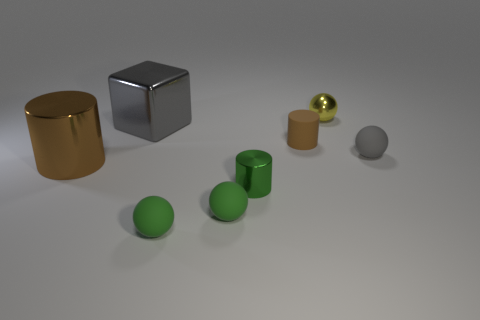Do the rubber cylinder and the large metallic cylinder have the same color?
Ensure brevity in your answer.  Yes. There is a small yellow sphere behind the brown matte cylinder; are there any tiny rubber balls that are on the left side of it?
Keep it short and to the point. Yes. What number of big things are in front of the tiny brown rubber cylinder?
Your response must be concise. 1. The big thing that is the same shape as the small green shiny thing is what color?
Your response must be concise. Brown. Is the big thing that is in front of the big gray thing made of the same material as the small cylinder behind the tiny gray matte thing?
Give a very brief answer. No. Is the color of the matte cylinder the same as the large object in front of the small gray sphere?
Your answer should be very brief. Yes. There is a shiny object that is behind the gray rubber thing and in front of the yellow shiny object; what is its shape?
Provide a succinct answer. Cube. What number of gray rubber objects are there?
Make the answer very short. 1. The tiny matte object that is the same color as the block is what shape?
Your answer should be compact. Sphere. There is a yellow thing that is the same shape as the tiny gray matte object; what size is it?
Offer a terse response. Small. 